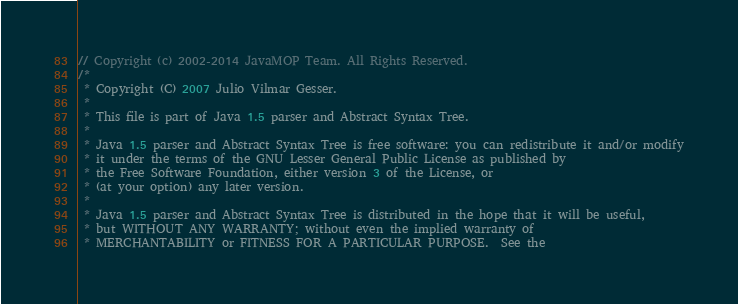<code> <loc_0><loc_0><loc_500><loc_500><_Java_>// Copyright (c) 2002-2014 JavaMOP Team. All Rights Reserved.
/*
 * Copyright (C) 2007 Julio Vilmar Gesser.
 * 
 * This file is part of Java 1.5 parser and Abstract Syntax Tree.
 *
 * Java 1.5 parser and Abstract Syntax Tree is free software: you can redistribute it and/or modify
 * it under the terms of the GNU Lesser General Public License as published by
 * the Free Software Foundation, either version 3 of the License, or
 * (at your option) any later version.
 *
 * Java 1.5 parser and Abstract Syntax Tree is distributed in the hope that it will be useful,
 * but WITHOUT ANY WARRANTY; without even the implied warranty of
 * MERCHANTABILITY or FITNESS FOR A PARTICULAR PURPOSE.  See the</code> 